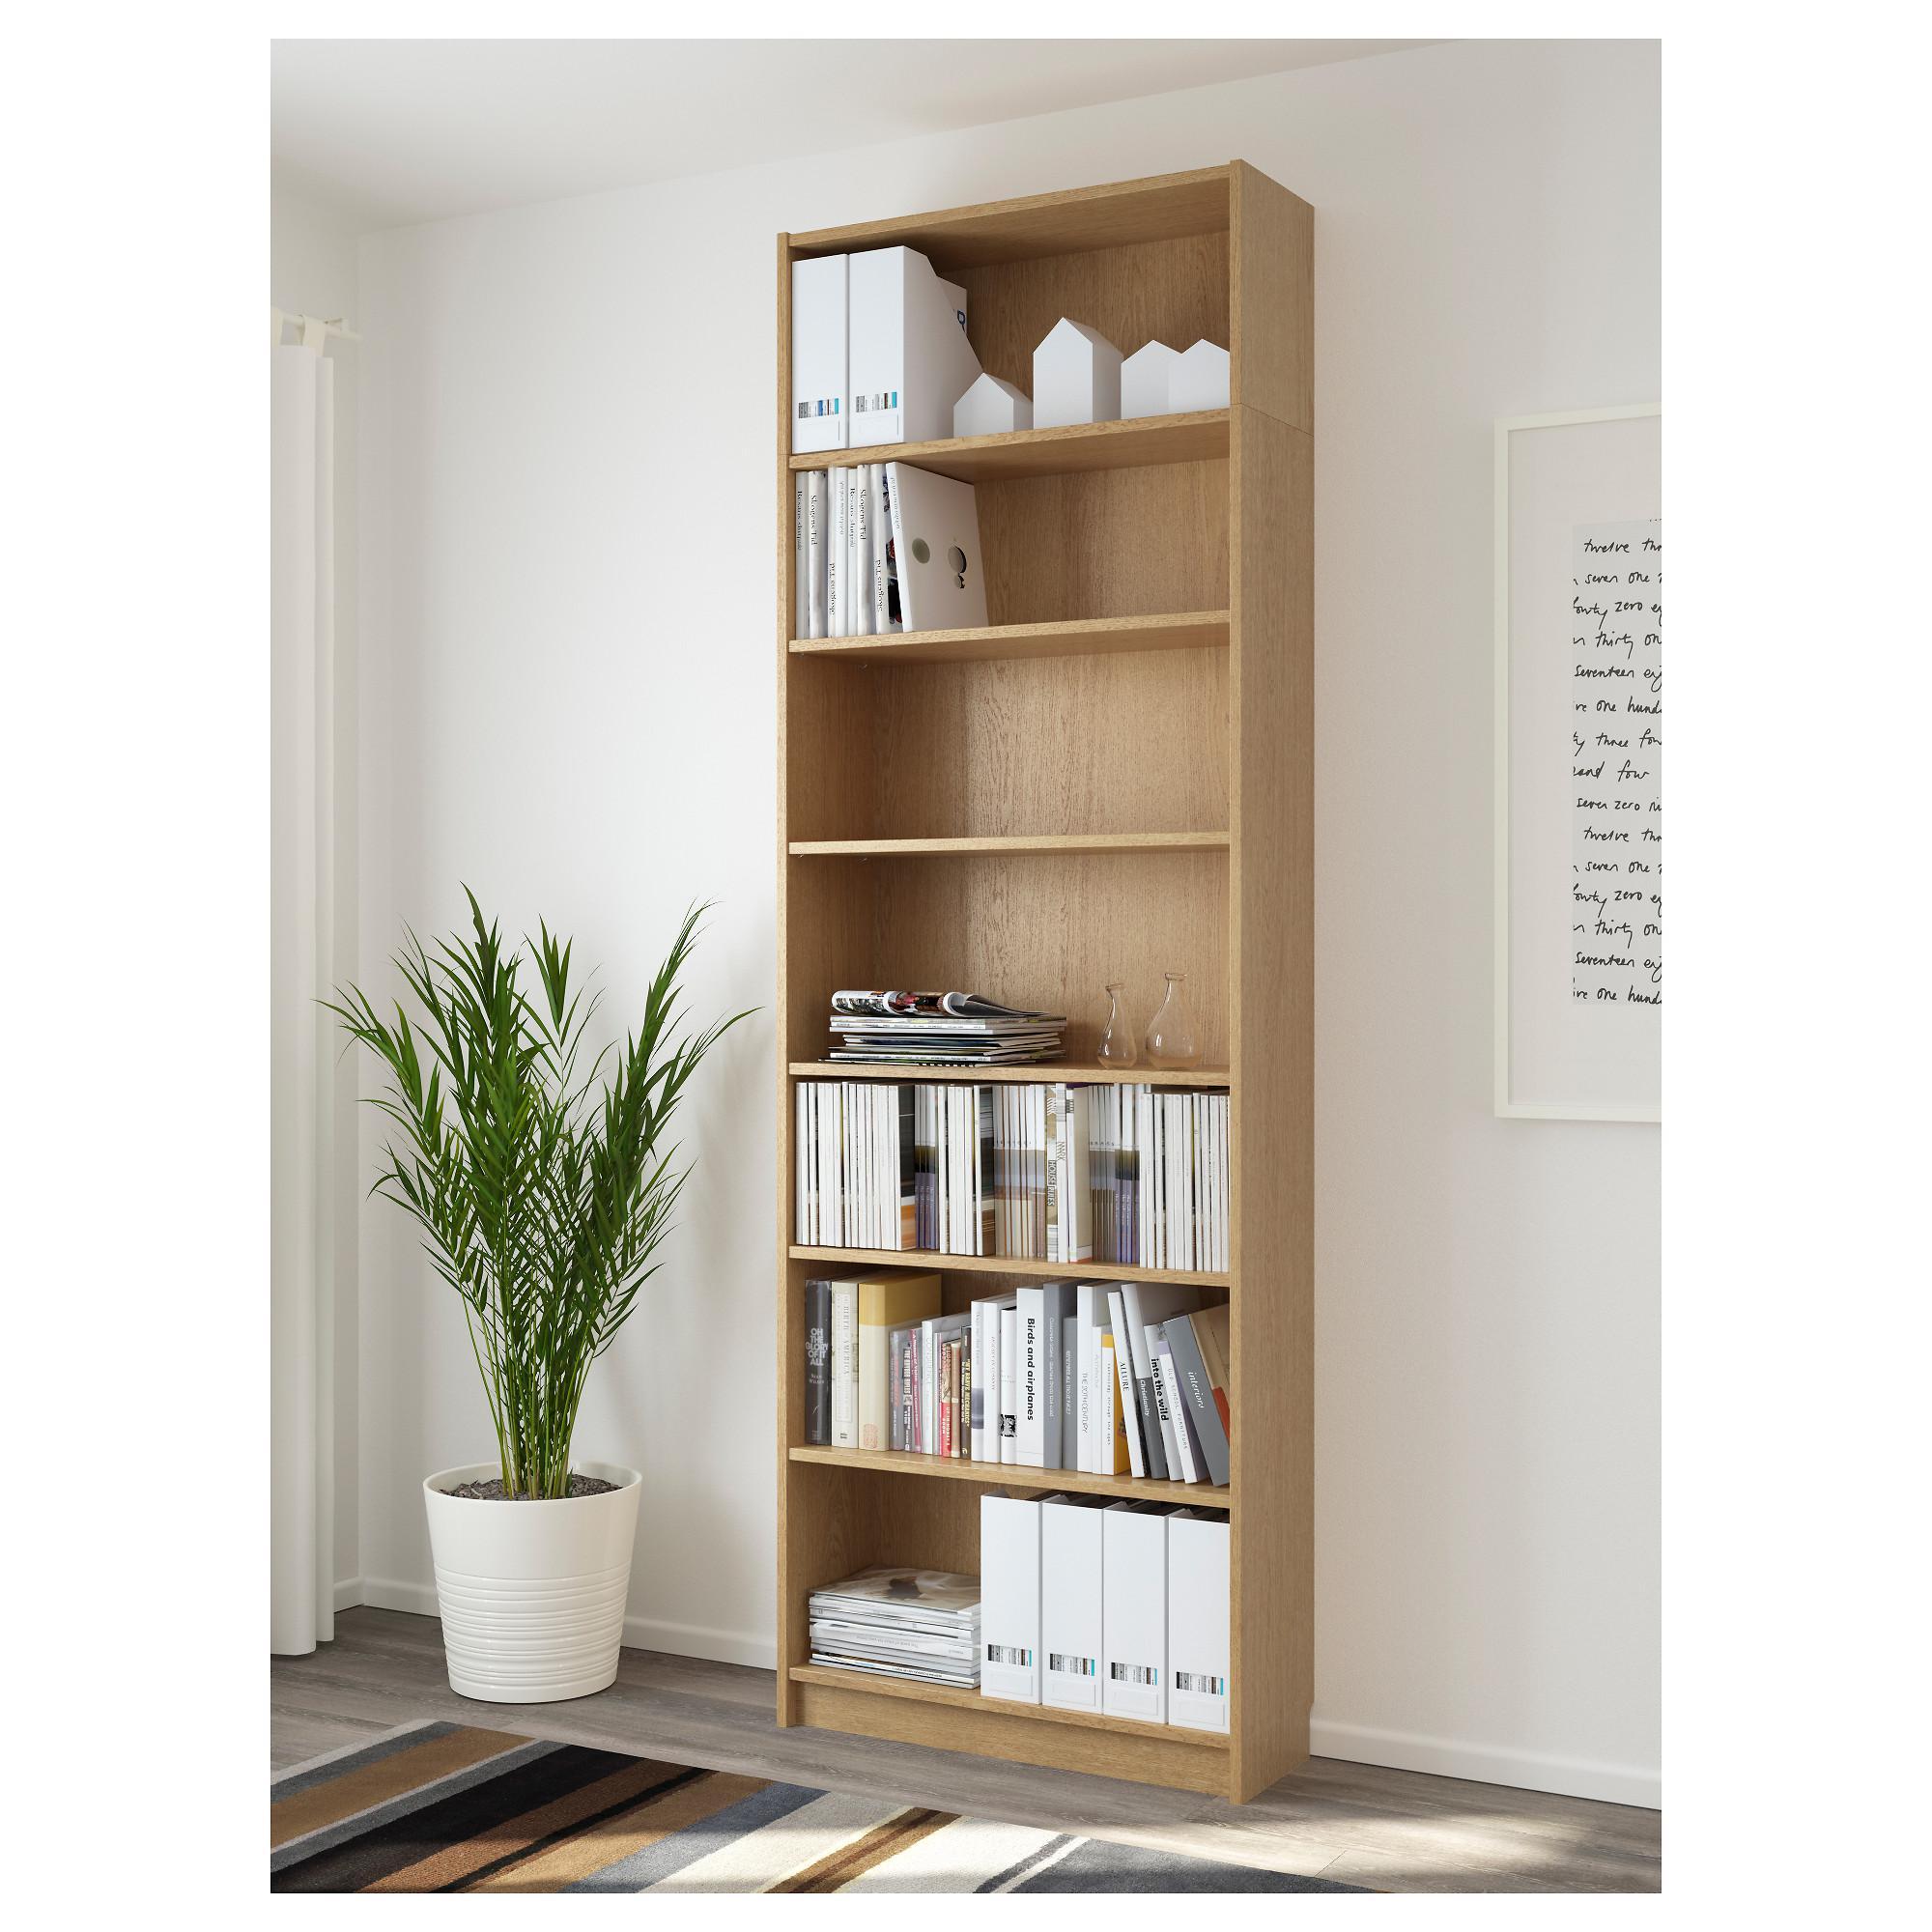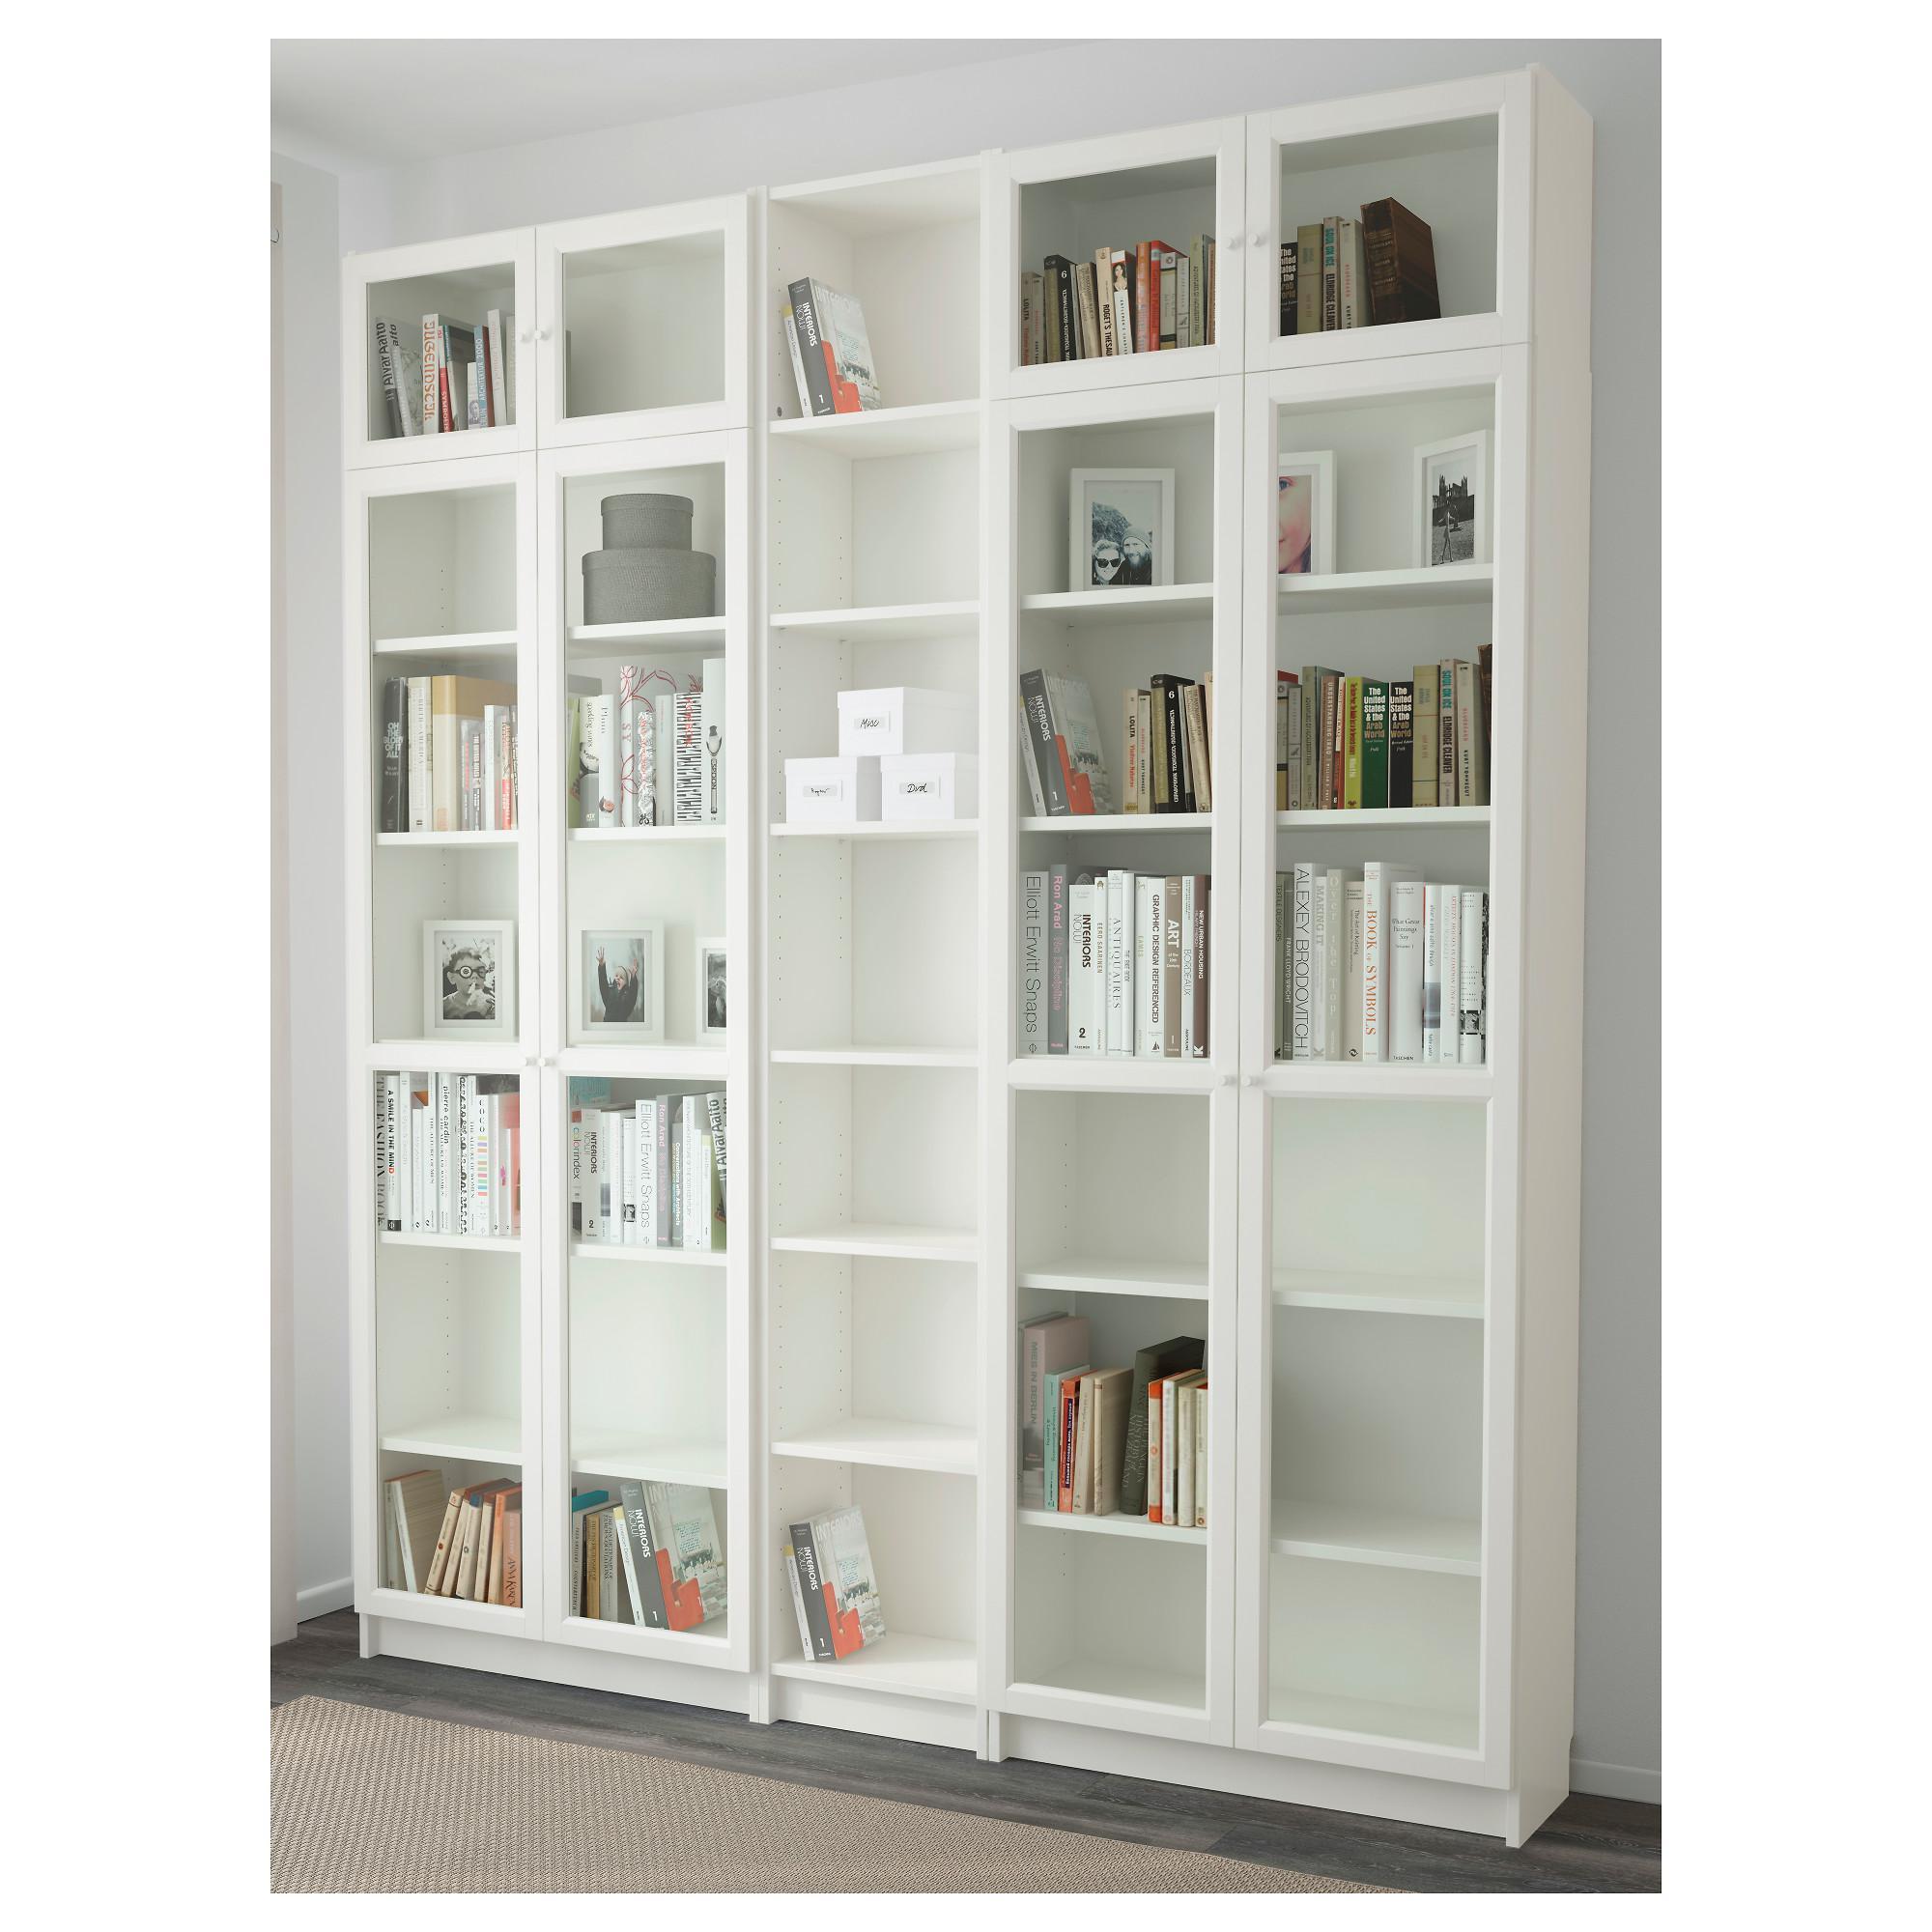The first image is the image on the left, the second image is the image on the right. Considering the images on both sides, is "The left image contains a bookshelf that is not white." valid? Answer yes or no. Yes. 